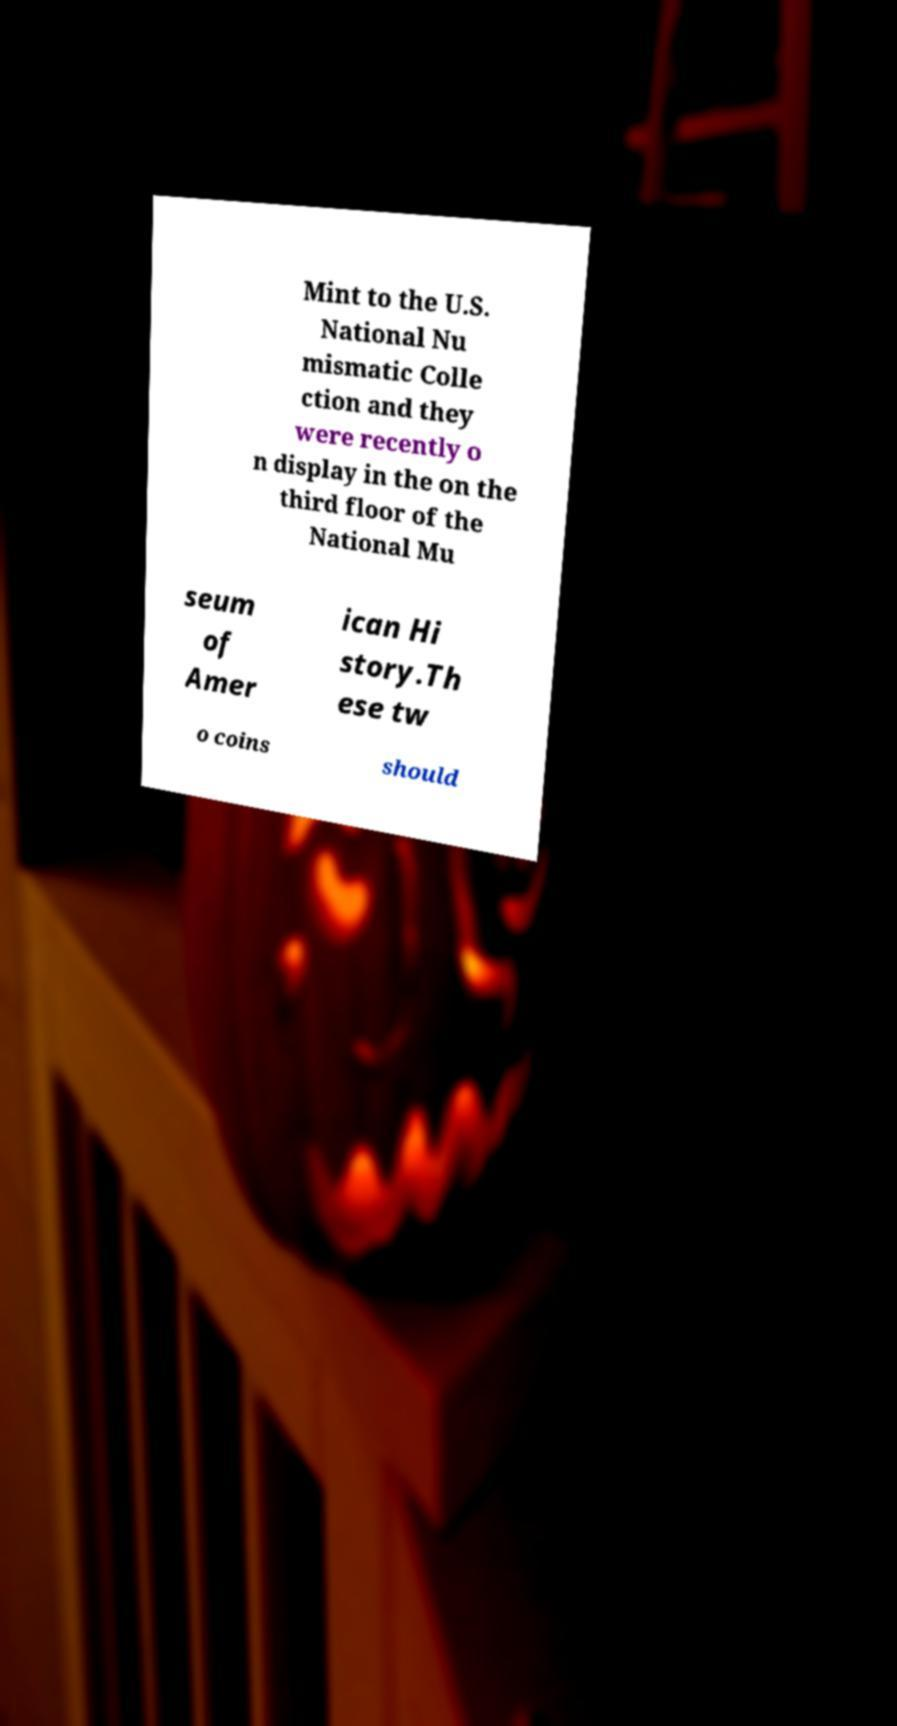Please read and relay the text visible in this image. What does it say? Mint to the U.S. National Nu mismatic Colle ction and they were recently o n display in the on the third floor of the National Mu seum of Amer ican Hi story.Th ese tw o coins should 